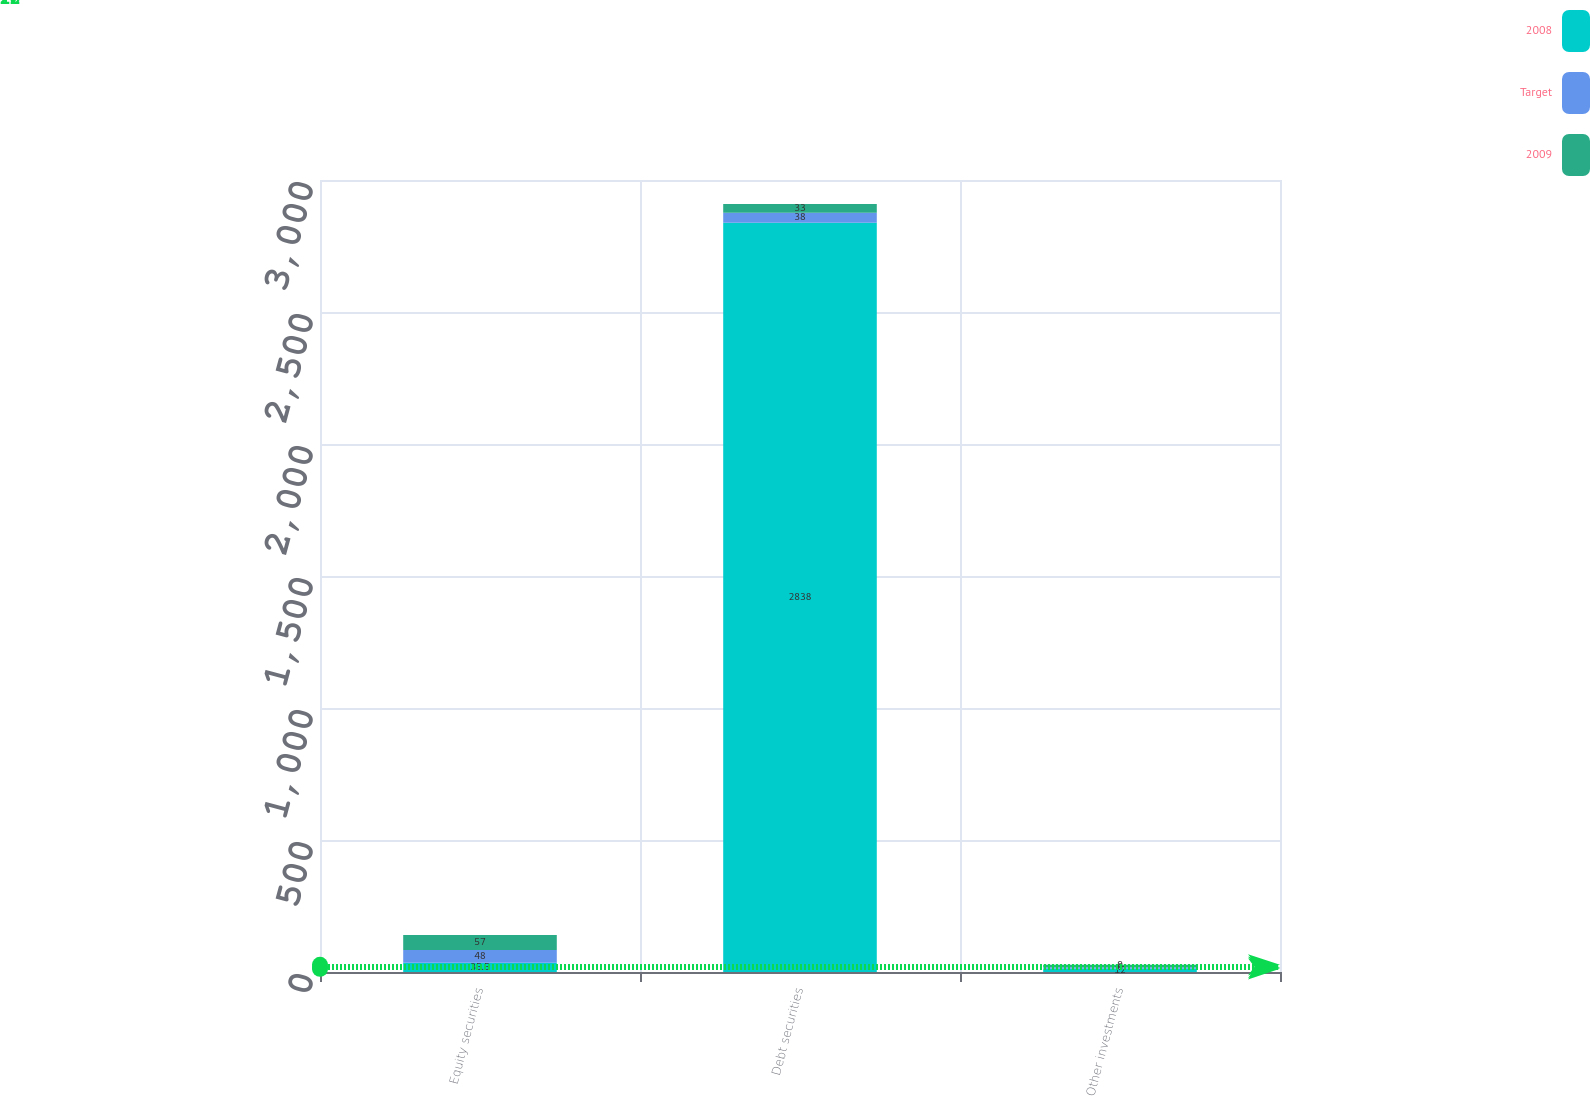<chart> <loc_0><loc_0><loc_500><loc_500><stacked_bar_chart><ecel><fcel>Equity securities<fcel>Debt securities<fcel>Other investments<nl><fcel>2008<fcel>35.5<fcel>2838<fcel>12<nl><fcel>Target<fcel>48<fcel>38<fcel>6<nl><fcel>2009<fcel>57<fcel>33<fcel>9<nl></chart> 